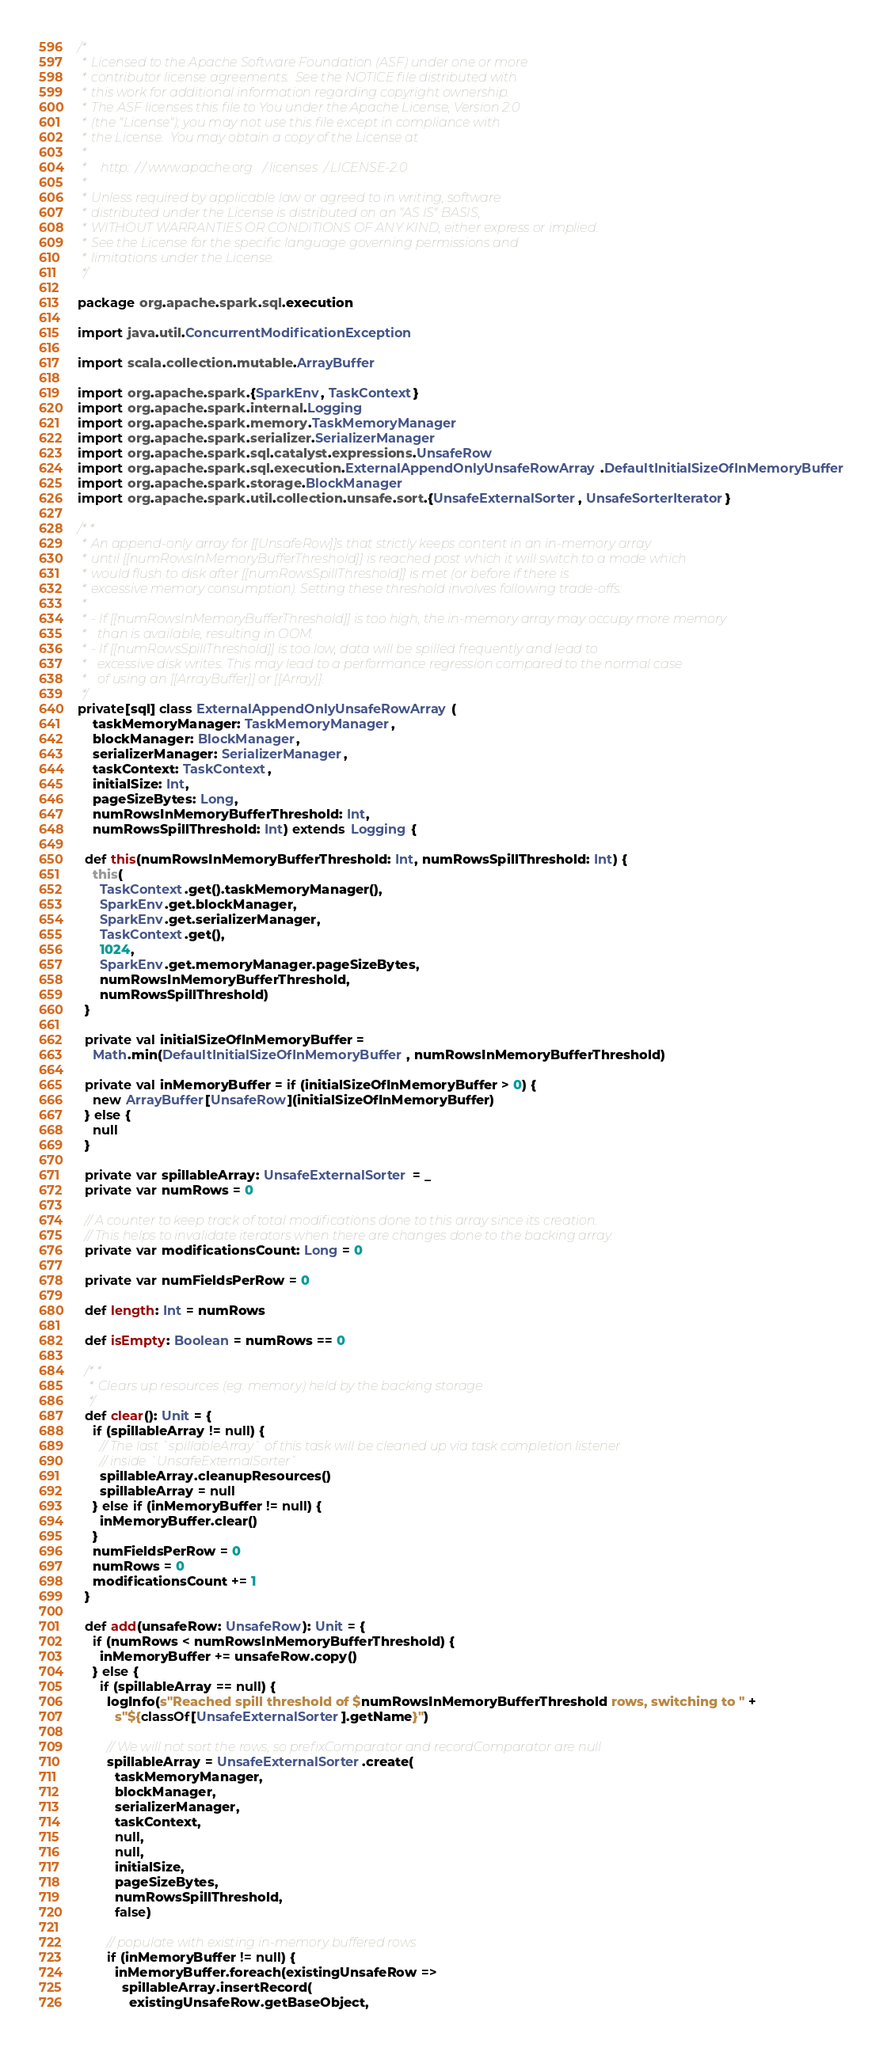Convert code to text. <code><loc_0><loc_0><loc_500><loc_500><_Scala_>/*
 * Licensed to the Apache Software Foundation (ASF) under one or more
 * contributor license agreements.  See the NOTICE file distributed with
 * this work for additional information regarding copyright ownership.
 * The ASF licenses this file to You under the Apache License, Version 2.0
 * (the "License"); you may not use this file except in compliance with
 * the License.  You may obtain a copy of the License at
 *
 *    http://www.apache.org/licenses/LICENSE-2.0
 *
 * Unless required by applicable law or agreed to in writing, software
 * distributed under the License is distributed on an "AS IS" BASIS,
 * WITHOUT WARRANTIES OR CONDITIONS OF ANY KIND, either express or implied.
 * See the License for the specific language governing permissions and
 * limitations under the License.
 */

package org.apache.spark.sql.execution

import java.util.ConcurrentModificationException

import scala.collection.mutable.ArrayBuffer

import org.apache.spark.{SparkEnv, TaskContext}
import org.apache.spark.internal.Logging
import org.apache.spark.memory.TaskMemoryManager
import org.apache.spark.serializer.SerializerManager
import org.apache.spark.sql.catalyst.expressions.UnsafeRow
import org.apache.spark.sql.execution.ExternalAppendOnlyUnsafeRowArray.DefaultInitialSizeOfInMemoryBuffer
import org.apache.spark.storage.BlockManager
import org.apache.spark.util.collection.unsafe.sort.{UnsafeExternalSorter, UnsafeSorterIterator}

/**
 * An append-only array for [[UnsafeRow]]s that strictly keeps content in an in-memory array
 * until [[numRowsInMemoryBufferThreshold]] is reached post which it will switch to a mode which
 * would flush to disk after [[numRowsSpillThreshold]] is met (or before if there is
 * excessive memory consumption). Setting these threshold involves following trade-offs:
 *
 * - If [[numRowsInMemoryBufferThreshold]] is too high, the in-memory array may occupy more memory
 *   than is available, resulting in OOM.
 * - If [[numRowsSpillThreshold]] is too low, data will be spilled frequently and lead to
 *   excessive disk writes. This may lead to a performance regression compared to the normal case
 *   of using an [[ArrayBuffer]] or [[Array]].
 */
private[sql] class ExternalAppendOnlyUnsafeRowArray(
    taskMemoryManager: TaskMemoryManager,
    blockManager: BlockManager,
    serializerManager: SerializerManager,
    taskContext: TaskContext,
    initialSize: Int,
    pageSizeBytes: Long,
    numRowsInMemoryBufferThreshold: Int,
    numRowsSpillThreshold: Int) extends Logging {

  def this(numRowsInMemoryBufferThreshold: Int, numRowsSpillThreshold: Int) {
    this(
      TaskContext.get().taskMemoryManager(),
      SparkEnv.get.blockManager,
      SparkEnv.get.serializerManager,
      TaskContext.get(),
      1024,
      SparkEnv.get.memoryManager.pageSizeBytes,
      numRowsInMemoryBufferThreshold,
      numRowsSpillThreshold)
  }

  private val initialSizeOfInMemoryBuffer =
    Math.min(DefaultInitialSizeOfInMemoryBuffer, numRowsInMemoryBufferThreshold)

  private val inMemoryBuffer = if (initialSizeOfInMemoryBuffer > 0) {
    new ArrayBuffer[UnsafeRow](initialSizeOfInMemoryBuffer)
  } else {
    null
  }

  private var spillableArray: UnsafeExternalSorter = _
  private var numRows = 0

  // A counter to keep track of total modifications done to this array since its creation.
  // This helps to invalidate iterators when there are changes done to the backing array.
  private var modificationsCount: Long = 0

  private var numFieldsPerRow = 0

  def length: Int = numRows

  def isEmpty: Boolean = numRows == 0

  /**
   * Clears up resources (eg. memory) held by the backing storage
   */
  def clear(): Unit = {
    if (spillableArray != null) {
      // The last `spillableArray` of this task will be cleaned up via task completion listener
      // inside `UnsafeExternalSorter`
      spillableArray.cleanupResources()
      spillableArray = null
    } else if (inMemoryBuffer != null) {
      inMemoryBuffer.clear()
    }
    numFieldsPerRow = 0
    numRows = 0
    modificationsCount += 1
  }

  def add(unsafeRow: UnsafeRow): Unit = {
    if (numRows < numRowsInMemoryBufferThreshold) {
      inMemoryBuffer += unsafeRow.copy()
    } else {
      if (spillableArray == null) {
        logInfo(s"Reached spill threshold of $numRowsInMemoryBufferThreshold rows, switching to " +
          s"${classOf[UnsafeExternalSorter].getName}")

        // We will not sort the rows, so prefixComparator and recordComparator are null
        spillableArray = UnsafeExternalSorter.create(
          taskMemoryManager,
          blockManager,
          serializerManager,
          taskContext,
          null,
          null,
          initialSize,
          pageSizeBytes,
          numRowsSpillThreshold,
          false)

        // populate with existing in-memory buffered rows
        if (inMemoryBuffer != null) {
          inMemoryBuffer.foreach(existingUnsafeRow =>
            spillableArray.insertRecord(
              existingUnsafeRow.getBaseObject,</code> 